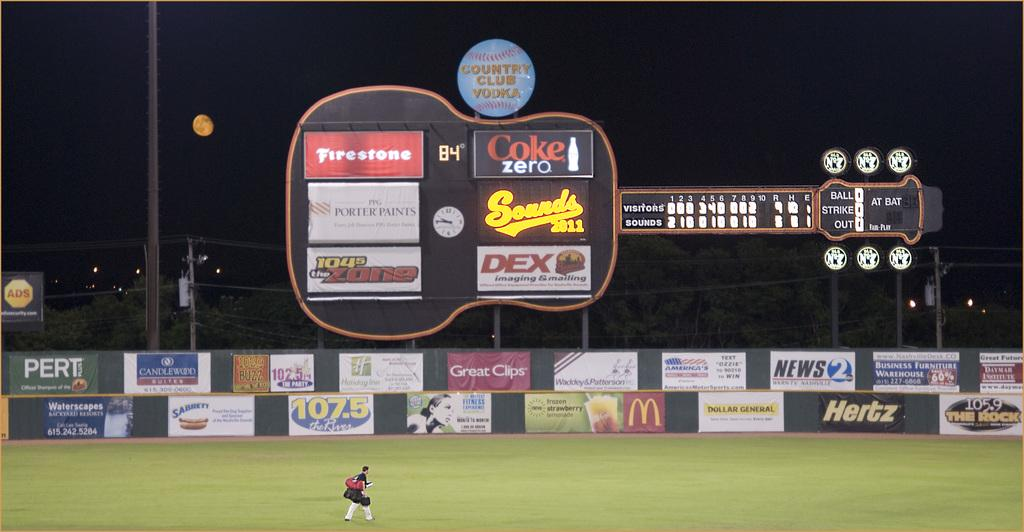<image>
Provide a brief description of the given image. Baseball stadium that has an ad for Coke Zero. 